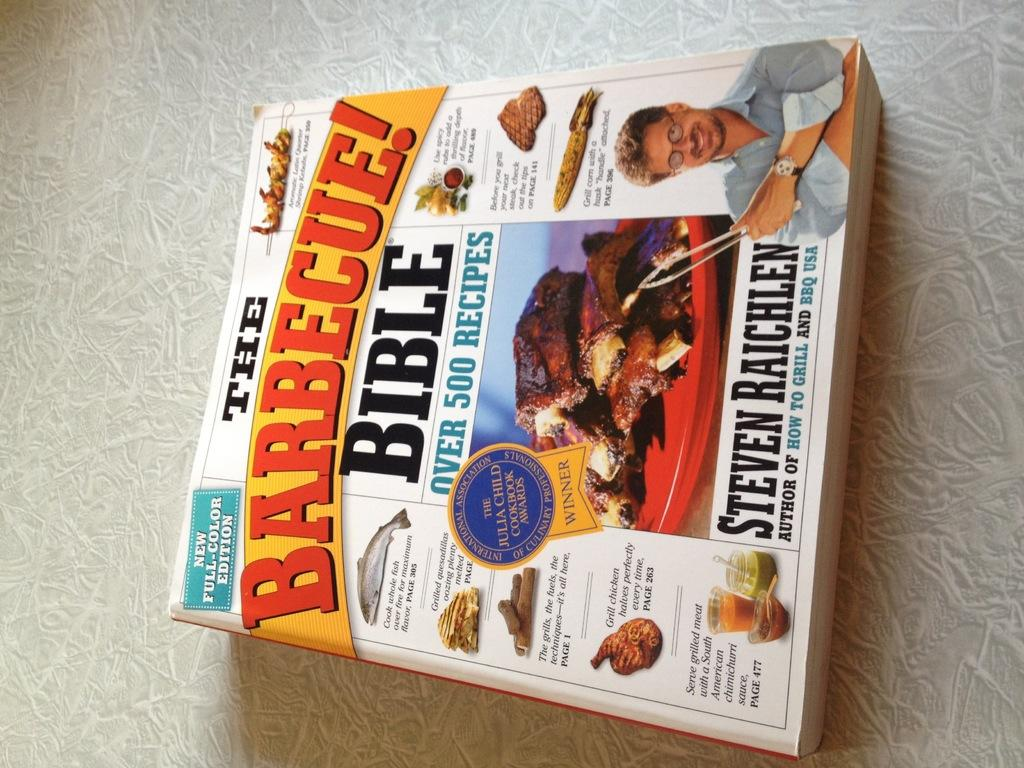<image>
Render a clear and concise summary of the photo. Serious cookout fans should avail themselves of the Barbecue! Bible. 